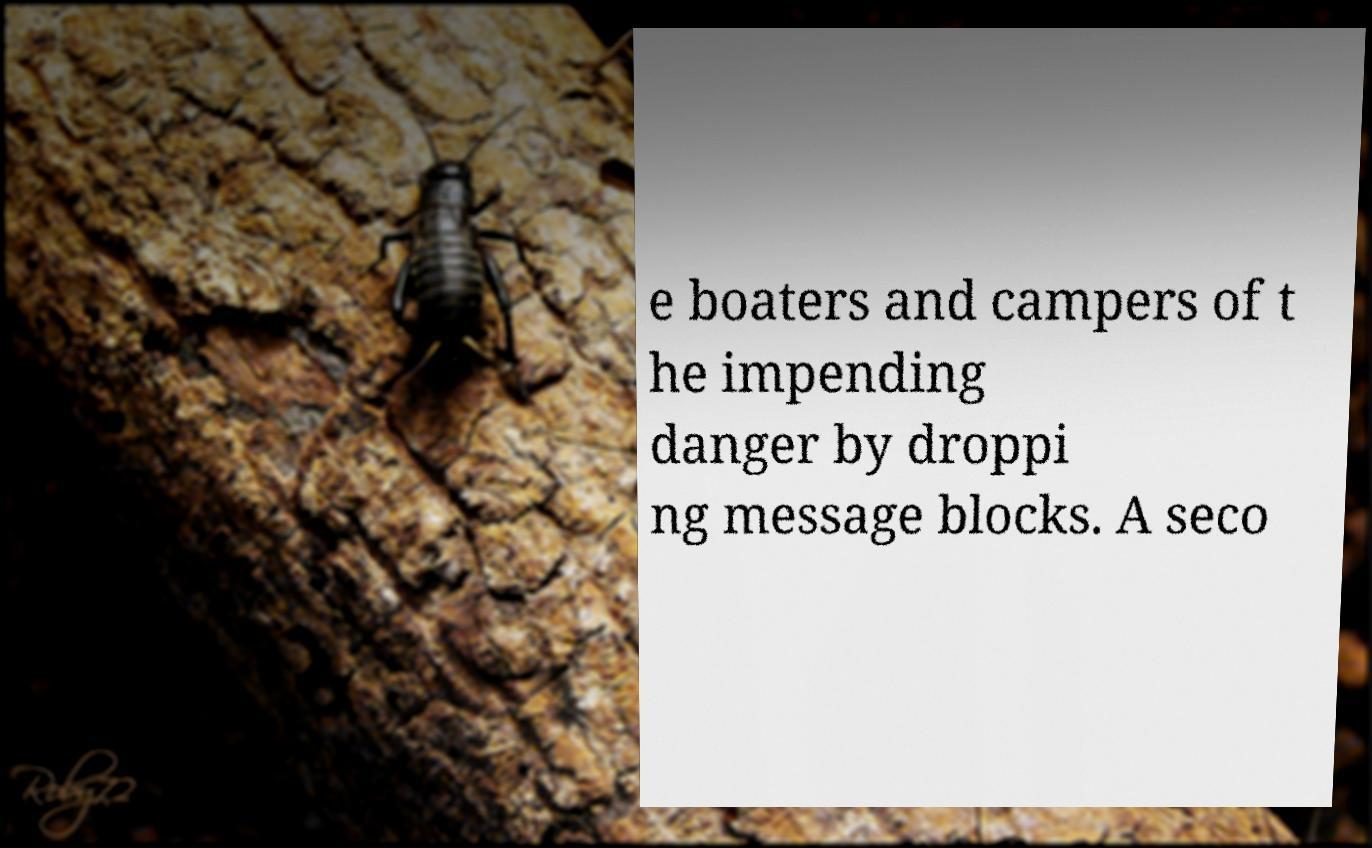Could you extract and type out the text from this image? e boaters and campers of t he impending danger by droppi ng message blocks. A seco 